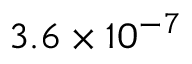<formula> <loc_0><loc_0><loc_500><loc_500>3 . 6 \times 1 0 ^ { - 7 }</formula> 